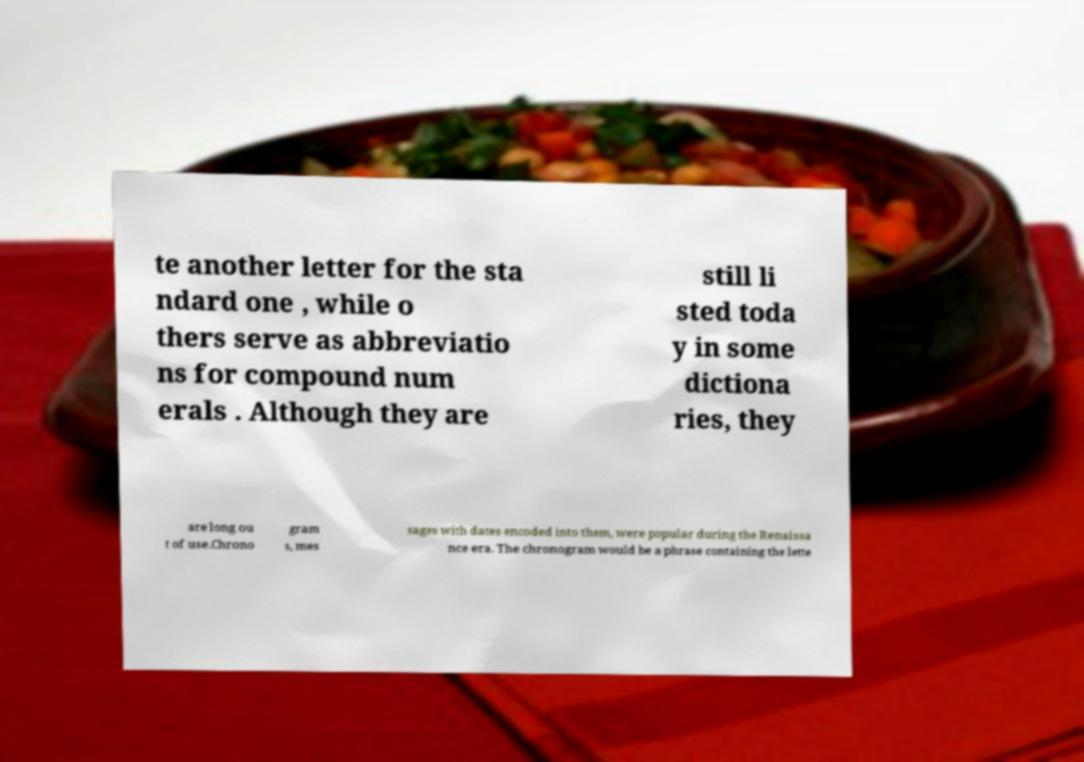Could you assist in decoding the text presented in this image and type it out clearly? te another letter for the sta ndard one , while o thers serve as abbreviatio ns for compound num erals . Although they are still li sted toda y in some dictiona ries, they are long ou t of use.Chrono gram s, mes sages with dates encoded into them, were popular during the Renaissa nce era. The chronogram would be a phrase containing the lette 